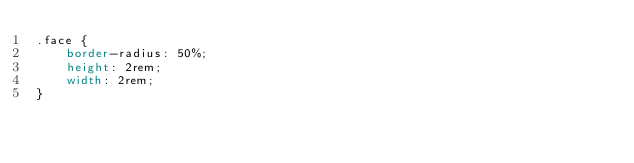<code> <loc_0><loc_0><loc_500><loc_500><_CSS_>.face {
    border-radius: 50%;
    height: 2rem;
    width: 2rem;
}</code> 